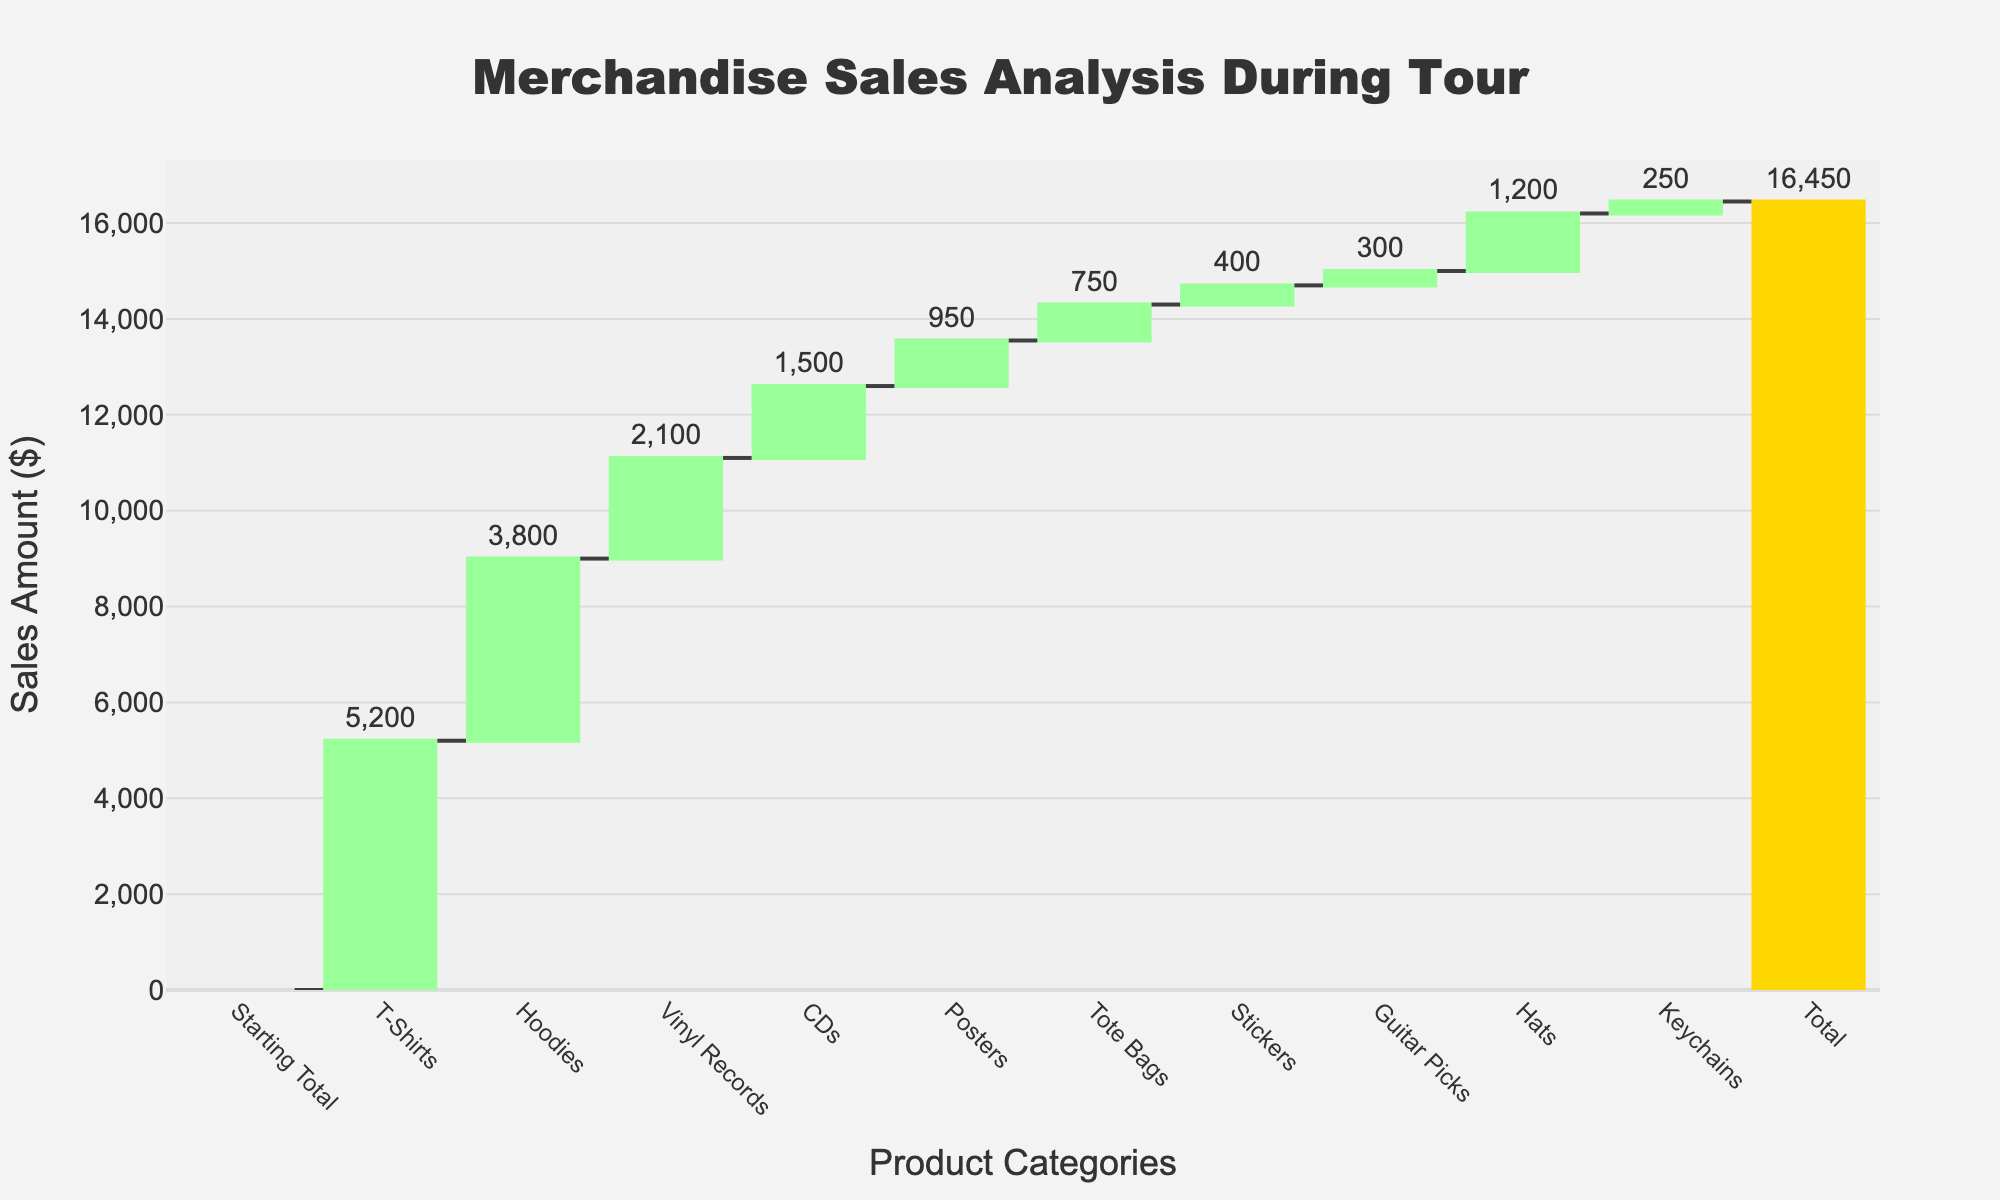What's the title of the figure? The title is usually displayed at the top of the figure. For this figure, it states the purpose of the chart.
Answer: Merchandise Sales Analysis During Tour What's the total merchandise sales amount during the tour? The total sales amount is displayed at the end of the Waterfall Chart, usually highlighted in a different color to signify it's a total. Looking at the chart, the total amount is shown in a golden bar.
Answer: $16,450 How much revenue came from T-Shirts compared to Hoodies? To find the revenue comparison, look at the heights of the green bars corresponding to T-Shirts and Hoodies. The T-Shirts have a value of $5,200 and the Hoodies have a value of $3,800.
Answer: T-Shirts: $5,200, Hoodies: $3,800 Which product category had the highest sales? The highest sales figure can be identified by finding the tallest green bar, which represents the increasing values.
Answer: T-Shirts What's the combined revenue from Vinyl Records and CDs? To get the combined revenue, sum the sales figures for Vinyl Records and CDs. Vinyl Records: $2,100, CDs: $1,500. So, $2,100 + $1,500 = $3,600.
Answer: $3,600 Which products contributed the least to overall sales? The smallest values are represented by the shortest green bars. From the chart, these are Stickers and Keychains, with sales amounts of $400 and $250 respectively.
Answer: Stickers and Keychains By how much did Hats sales surpass Hoodies sales? To find this difference, subtract the sales of Hoodies from that of Hats. Hats: $1,200 - Hoodies: $3,800. The difference is $1,200 - $3,800 = -$2,600, meaning Hoodies sales surpass Hats sales.
Answer: $2,600 (Hoodies > Hats) How does the sales increase from Posters to Tote Bags compare to the increase from Tote Bags to Stickers? To find the differences, calculate Posters to Tote Bags ($750 - $950 = -$200) and Tote Bags to Stickers ($400 - $750 = -$350). Compare these two values: -$200 vs. -$350.
Answer: From Posters to Tote Bags: $200 less, From Tote Bags to Stickers: $350 less What is the average sales amount per product category? To find the average, divide the total sales amount by the number of product categories excluding the starting total. $16,450 divided by 10 categories = $1,645 per category.
Answer: $1,645 Which product categories have sales below the average sales amount? Compare each category's sales value to the average sales amount ($1,645). Categories below this amount are Posters, Tote Bags, Stickers, Guitar Picks, Hats, and Keychains.
Answer: Posters, Tote Bags, Stickers, Guitar Picks, Hats, and Keychains 